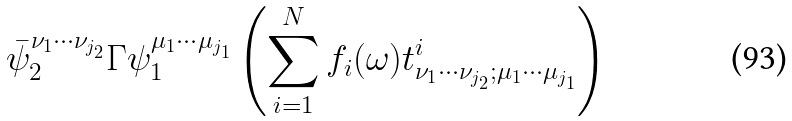<formula> <loc_0><loc_0><loc_500><loc_500>\bar { \psi } _ { 2 } ^ { \nu _ { 1 } \cdots \nu _ { j _ { 2 } } } \Gamma \psi _ { 1 } ^ { \mu _ { 1 } \cdots \mu _ { j _ { 1 } } } \left ( \sum _ { i = 1 } ^ { N } f _ { i } ( \omega ) t ^ { i } _ { \nu _ { 1 } \cdots \nu _ { j _ { 2 } } ; \mu _ { 1 } \cdots \mu _ { j _ { 1 } } } \right )</formula> 